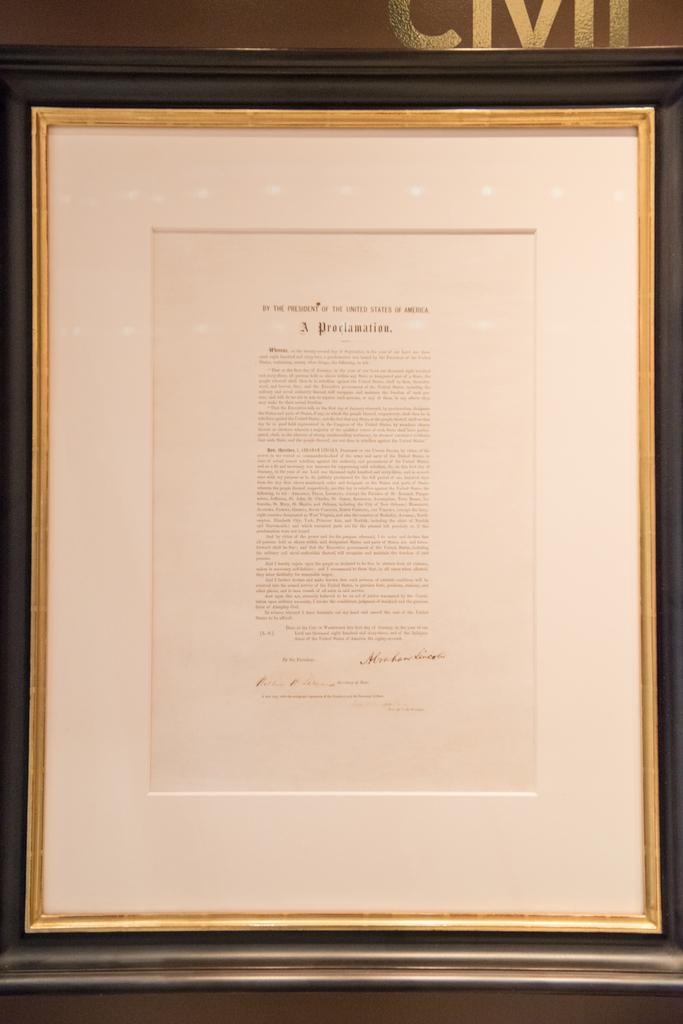<image>
Offer a succinct explanation of the picture presented. Article framed on a wall that starts with "A Proclamation". 